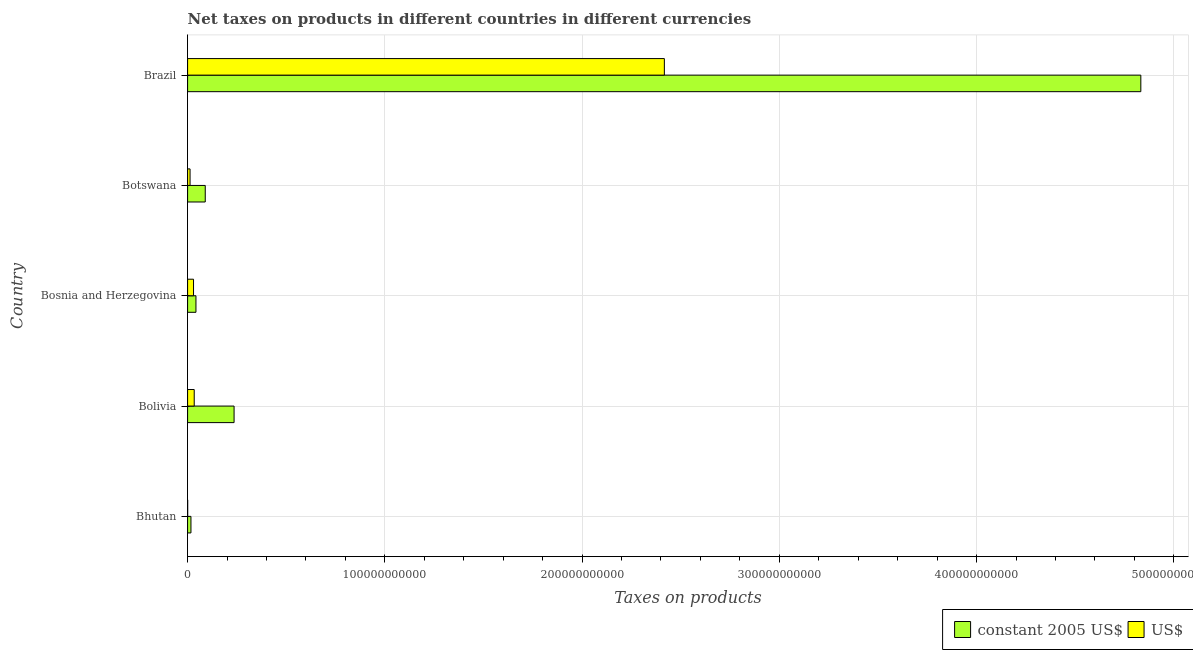How many different coloured bars are there?
Ensure brevity in your answer.  2. Are the number of bars on each tick of the Y-axis equal?
Offer a terse response. Yes. How many bars are there on the 3rd tick from the top?
Ensure brevity in your answer.  2. How many bars are there on the 3rd tick from the bottom?
Your response must be concise. 2. In how many cases, is the number of bars for a given country not equal to the number of legend labels?
Your response must be concise. 0. What is the net taxes in constant 2005 us$ in Bhutan?
Give a very brief answer. 1.70e+09. Across all countries, what is the maximum net taxes in us$?
Keep it short and to the point. 2.42e+11. Across all countries, what is the minimum net taxes in constant 2005 us$?
Make the answer very short. 1.70e+09. In which country was the net taxes in constant 2005 us$ minimum?
Offer a terse response. Bhutan. What is the total net taxes in constant 2005 us$ in the graph?
Provide a succinct answer. 5.22e+11. What is the difference between the net taxes in us$ in Bhutan and that in Bolivia?
Keep it short and to the point. -3.32e+09. What is the difference between the net taxes in us$ in Botswana and the net taxes in constant 2005 us$ in Bosnia and Herzegovina?
Ensure brevity in your answer.  -2.99e+09. What is the average net taxes in constant 2005 us$ per country?
Your answer should be compact. 1.04e+11. What is the difference between the net taxes in us$ and net taxes in constant 2005 us$ in Bolivia?
Provide a short and direct response. -2.02e+1. In how many countries, is the net taxes in constant 2005 us$ greater than 40000000000 units?
Provide a succinct answer. 1. What is the ratio of the net taxes in us$ in Bhutan to that in Bolivia?
Offer a very short reply. 0.01. Is the net taxes in constant 2005 us$ in Bhutan less than that in Brazil?
Your answer should be very brief. Yes. Is the difference between the net taxes in constant 2005 us$ in Bhutan and Botswana greater than the difference between the net taxes in us$ in Bhutan and Botswana?
Make the answer very short. No. What is the difference between the highest and the second highest net taxes in us$?
Your response must be concise. 2.38e+11. What is the difference between the highest and the lowest net taxes in us$?
Your answer should be compact. 2.42e+11. What does the 1st bar from the top in Bosnia and Herzegovina represents?
Keep it short and to the point. US$. What does the 1st bar from the bottom in Bosnia and Herzegovina represents?
Give a very brief answer. Constant 2005 us$. How many bars are there?
Ensure brevity in your answer.  10. Are all the bars in the graph horizontal?
Give a very brief answer. Yes. What is the difference between two consecutive major ticks on the X-axis?
Provide a succinct answer. 1.00e+11. Does the graph contain any zero values?
Offer a terse response. No. Does the graph contain grids?
Give a very brief answer. Yes. How many legend labels are there?
Keep it short and to the point. 2. What is the title of the graph?
Offer a terse response. Net taxes on products in different countries in different currencies. What is the label or title of the X-axis?
Ensure brevity in your answer.  Taxes on products. What is the label or title of the Y-axis?
Offer a very short reply. Country. What is the Taxes on products in constant 2005 US$ in Bhutan?
Provide a short and direct response. 1.70e+09. What is the Taxes on products of US$ in Bhutan?
Ensure brevity in your answer.  3.52e+07. What is the Taxes on products of constant 2005 US$ in Bolivia?
Give a very brief answer. 2.36e+1. What is the Taxes on products in US$ in Bolivia?
Ensure brevity in your answer.  3.36e+09. What is the Taxes on products of constant 2005 US$ in Bosnia and Herzegovina?
Provide a succinct answer. 4.24e+09. What is the Taxes on products in US$ in Bosnia and Herzegovina?
Provide a succinct answer. 3.01e+09. What is the Taxes on products in constant 2005 US$ in Botswana?
Your response must be concise. 8.95e+09. What is the Taxes on products of US$ in Botswana?
Your response must be concise. 1.25e+09. What is the Taxes on products of constant 2005 US$ in Brazil?
Provide a short and direct response. 4.83e+11. What is the Taxes on products in US$ in Brazil?
Provide a short and direct response. 2.42e+11. Across all countries, what is the maximum Taxes on products in constant 2005 US$?
Give a very brief answer. 4.83e+11. Across all countries, what is the maximum Taxes on products of US$?
Your response must be concise. 2.42e+11. Across all countries, what is the minimum Taxes on products of constant 2005 US$?
Your answer should be compact. 1.70e+09. Across all countries, what is the minimum Taxes on products in US$?
Provide a succinct answer. 3.52e+07. What is the total Taxes on products in constant 2005 US$ in the graph?
Provide a succinct answer. 5.22e+11. What is the total Taxes on products of US$ in the graph?
Ensure brevity in your answer.  2.49e+11. What is the difference between the Taxes on products of constant 2005 US$ in Bhutan and that in Bolivia?
Provide a succinct answer. -2.19e+1. What is the difference between the Taxes on products in US$ in Bhutan and that in Bolivia?
Offer a very short reply. -3.32e+09. What is the difference between the Taxes on products of constant 2005 US$ in Bhutan and that in Bosnia and Herzegovina?
Your response must be concise. -2.53e+09. What is the difference between the Taxes on products in US$ in Bhutan and that in Bosnia and Herzegovina?
Provide a succinct answer. -2.98e+09. What is the difference between the Taxes on products in constant 2005 US$ in Bhutan and that in Botswana?
Offer a terse response. -7.24e+09. What is the difference between the Taxes on products of US$ in Bhutan and that in Botswana?
Ensure brevity in your answer.  -1.22e+09. What is the difference between the Taxes on products of constant 2005 US$ in Bhutan and that in Brazil?
Keep it short and to the point. -4.82e+11. What is the difference between the Taxes on products of US$ in Bhutan and that in Brazil?
Offer a very short reply. -2.42e+11. What is the difference between the Taxes on products in constant 2005 US$ in Bolivia and that in Bosnia and Herzegovina?
Provide a succinct answer. 1.93e+1. What is the difference between the Taxes on products of US$ in Bolivia and that in Bosnia and Herzegovina?
Give a very brief answer. 3.46e+08. What is the difference between the Taxes on products in constant 2005 US$ in Bolivia and that in Botswana?
Your answer should be compact. 1.46e+1. What is the difference between the Taxes on products of US$ in Bolivia and that in Botswana?
Offer a very short reply. 2.11e+09. What is the difference between the Taxes on products in constant 2005 US$ in Bolivia and that in Brazil?
Provide a short and direct response. -4.60e+11. What is the difference between the Taxes on products of US$ in Bolivia and that in Brazil?
Your answer should be compact. -2.38e+11. What is the difference between the Taxes on products of constant 2005 US$ in Bosnia and Herzegovina and that in Botswana?
Make the answer very short. -4.71e+09. What is the difference between the Taxes on products in US$ in Bosnia and Herzegovina and that in Botswana?
Make the answer very short. 1.76e+09. What is the difference between the Taxes on products of constant 2005 US$ in Bosnia and Herzegovina and that in Brazil?
Your answer should be compact. -4.79e+11. What is the difference between the Taxes on products of US$ in Bosnia and Herzegovina and that in Brazil?
Offer a terse response. -2.39e+11. What is the difference between the Taxes on products of constant 2005 US$ in Botswana and that in Brazil?
Give a very brief answer. -4.74e+11. What is the difference between the Taxes on products of US$ in Botswana and that in Brazil?
Make the answer very short. -2.40e+11. What is the difference between the Taxes on products of constant 2005 US$ in Bhutan and the Taxes on products of US$ in Bolivia?
Ensure brevity in your answer.  -1.65e+09. What is the difference between the Taxes on products in constant 2005 US$ in Bhutan and the Taxes on products in US$ in Bosnia and Herzegovina?
Your answer should be very brief. -1.31e+09. What is the difference between the Taxes on products in constant 2005 US$ in Bhutan and the Taxes on products in US$ in Botswana?
Provide a succinct answer. 4.54e+08. What is the difference between the Taxes on products of constant 2005 US$ in Bhutan and the Taxes on products of US$ in Brazil?
Your response must be concise. -2.40e+11. What is the difference between the Taxes on products in constant 2005 US$ in Bolivia and the Taxes on products in US$ in Bosnia and Herzegovina?
Give a very brief answer. 2.06e+1. What is the difference between the Taxes on products of constant 2005 US$ in Bolivia and the Taxes on products of US$ in Botswana?
Keep it short and to the point. 2.23e+1. What is the difference between the Taxes on products of constant 2005 US$ in Bolivia and the Taxes on products of US$ in Brazil?
Give a very brief answer. -2.18e+11. What is the difference between the Taxes on products of constant 2005 US$ in Bosnia and Herzegovina and the Taxes on products of US$ in Botswana?
Offer a very short reply. 2.99e+09. What is the difference between the Taxes on products in constant 2005 US$ in Bosnia and Herzegovina and the Taxes on products in US$ in Brazil?
Keep it short and to the point. -2.37e+11. What is the difference between the Taxes on products of constant 2005 US$ in Botswana and the Taxes on products of US$ in Brazil?
Your response must be concise. -2.33e+11. What is the average Taxes on products in constant 2005 US$ per country?
Your response must be concise. 1.04e+11. What is the average Taxes on products of US$ per country?
Provide a short and direct response. 4.99e+1. What is the difference between the Taxes on products in constant 2005 US$ and Taxes on products in US$ in Bhutan?
Provide a succinct answer. 1.67e+09. What is the difference between the Taxes on products in constant 2005 US$ and Taxes on products in US$ in Bolivia?
Your answer should be very brief. 2.02e+1. What is the difference between the Taxes on products of constant 2005 US$ and Taxes on products of US$ in Bosnia and Herzegovina?
Provide a short and direct response. 1.23e+09. What is the difference between the Taxes on products of constant 2005 US$ and Taxes on products of US$ in Botswana?
Your response must be concise. 7.70e+09. What is the difference between the Taxes on products in constant 2005 US$ and Taxes on products in US$ in Brazil?
Offer a terse response. 2.42e+11. What is the ratio of the Taxes on products in constant 2005 US$ in Bhutan to that in Bolivia?
Your answer should be compact. 0.07. What is the ratio of the Taxes on products of US$ in Bhutan to that in Bolivia?
Make the answer very short. 0.01. What is the ratio of the Taxes on products in constant 2005 US$ in Bhutan to that in Bosnia and Herzegovina?
Your answer should be very brief. 0.4. What is the ratio of the Taxes on products in US$ in Bhutan to that in Bosnia and Herzegovina?
Your response must be concise. 0.01. What is the ratio of the Taxes on products of constant 2005 US$ in Bhutan to that in Botswana?
Make the answer very short. 0.19. What is the ratio of the Taxes on products in US$ in Bhutan to that in Botswana?
Your response must be concise. 0.03. What is the ratio of the Taxes on products in constant 2005 US$ in Bhutan to that in Brazil?
Ensure brevity in your answer.  0. What is the ratio of the Taxes on products in constant 2005 US$ in Bolivia to that in Bosnia and Herzegovina?
Ensure brevity in your answer.  5.56. What is the ratio of the Taxes on products of US$ in Bolivia to that in Bosnia and Herzegovina?
Provide a succinct answer. 1.11. What is the ratio of the Taxes on products in constant 2005 US$ in Bolivia to that in Botswana?
Your answer should be compact. 2.63. What is the ratio of the Taxes on products in US$ in Bolivia to that in Botswana?
Offer a terse response. 2.68. What is the ratio of the Taxes on products of constant 2005 US$ in Bolivia to that in Brazil?
Offer a very short reply. 0.05. What is the ratio of the Taxes on products in US$ in Bolivia to that in Brazil?
Provide a succinct answer. 0.01. What is the ratio of the Taxes on products in constant 2005 US$ in Bosnia and Herzegovina to that in Botswana?
Ensure brevity in your answer.  0.47. What is the ratio of the Taxes on products of US$ in Bosnia and Herzegovina to that in Botswana?
Provide a succinct answer. 2.41. What is the ratio of the Taxes on products of constant 2005 US$ in Bosnia and Herzegovina to that in Brazil?
Ensure brevity in your answer.  0.01. What is the ratio of the Taxes on products in US$ in Bosnia and Herzegovina to that in Brazil?
Keep it short and to the point. 0.01. What is the ratio of the Taxes on products in constant 2005 US$ in Botswana to that in Brazil?
Offer a very short reply. 0.02. What is the ratio of the Taxes on products in US$ in Botswana to that in Brazil?
Provide a succinct answer. 0.01. What is the difference between the highest and the second highest Taxes on products of constant 2005 US$?
Your answer should be very brief. 4.60e+11. What is the difference between the highest and the second highest Taxes on products of US$?
Your answer should be very brief. 2.38e+11. What is the difference between the highest and the lowest Taxes on products in constant 2005 US$?
Give a very brief answer. 4.82e+11. What is the difference between the highest and the lowest Taxes on products in US$?
Provide a succinct answer. 2.42e+11. 